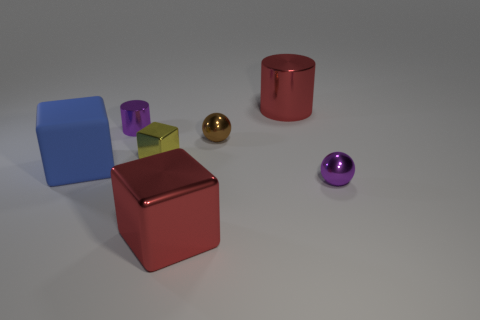Subtract all tiny yellow shiny blocks. How many blocks are left? 2 Add 2 metallic blocks. How many objects exist? 9 Subtract all red blocks. How many blocks are left? 2 Subtract 0 green spheres. How many objects are left? 7 Subtract all blocks. How many objects are left? 4 Subtract 2 balls. How many balls are left? 0 Subtract all brown balls. Subtract all red blocks. How many balls are left? 1 Subtract all green cylinders. How many purple cubes are left? 0 Subtract all large gray matte balls. Subtract all small brown balls. How many objects are left? 6 Add 5 yellow metallic blocks. How many yellow metallic blocks are left? 6 